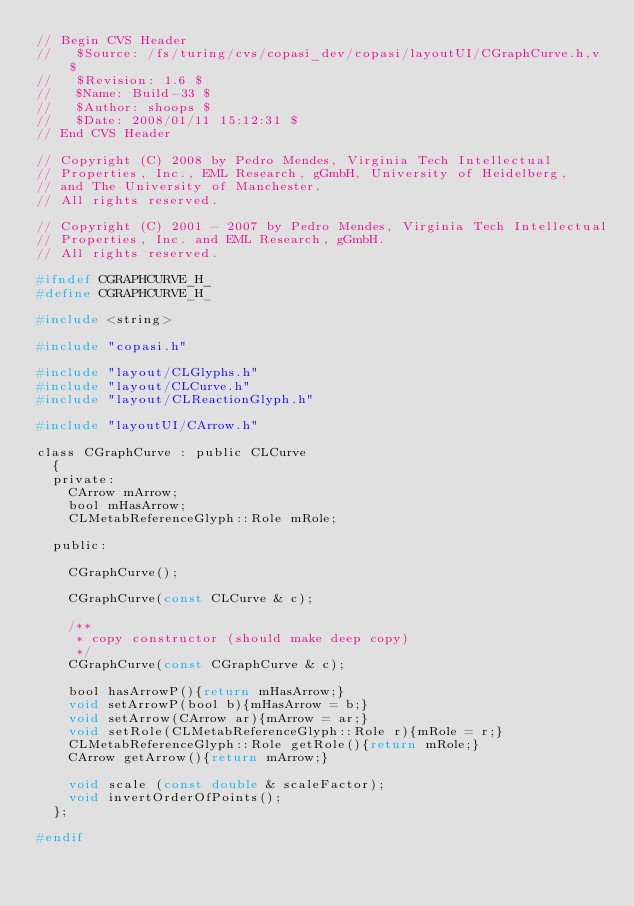Convert code to text. <code><loc_0><loc_0><loc_500><loc_500><_C_>// Begin CVS Header
//   $Source: /fs/turing/cvs/copasi_dev/copasi/layoutUI/CGraphCurve.h,v $
//   $Revision: 1.6 $
//   $Name: Build-33 $
//   $Author: shoops $
//   $Date: 2008/01/11 15:12:31 $
// End CVS Header

// Copyright (C) 2008 by Pedro Mendes, Virginia Tech Intellectual
// Properties, Inc., EML Research, gGmbH, University of Heidelberg,
// and The University of Manchester.
// All rights reserved.

// Copyright (C) 2001 - 2007 by Pedro Mendes, Virginia Tech Intellectual
// Properties, Inc. and EML Research, gGmbH.
// All rights reserved.

#ifndef CGRAPHCURVE_H_
#define CGRAPHCURVE_H_

#include <string>

#include "copasi.h"

#include "layout/CLGlyphs.h"
#include "layout/CLCurve.h"
#include "layout/CLReactionGlyph.h"

#include "layoutUI/CArrow.h"

class CGraphCurve : public CLCurve
  {
  private:
    CArrow mArrow;
    bool mHasArrow;
    CLMetabReferenceGlyph::Role mRole;

  public:

    CGraphCurve();

    CGraphCurve(const CLCurve & c);

    /**
     * copy constructor (should make deep copy)
     */
    CGraphCurve(const CGraphCurve & c);

    bool hasArrowP(){return mHasArrow;}
    void setArrowP(bool b){mHasArrow = b;}
    void setArrow(CArrow ar){mArrow = ar;}
    void setRole(CLMetabReferenceGlyph::Role r){mRole = r;}
    CLMetabReferenceGlyph::Role getRole(){return mRole;}
    CArrow getArrow(){return mArrow;}

    void scale (const double & scaleFactor);
    void invertOrderOfPoints();
  };

#endif
</code> 